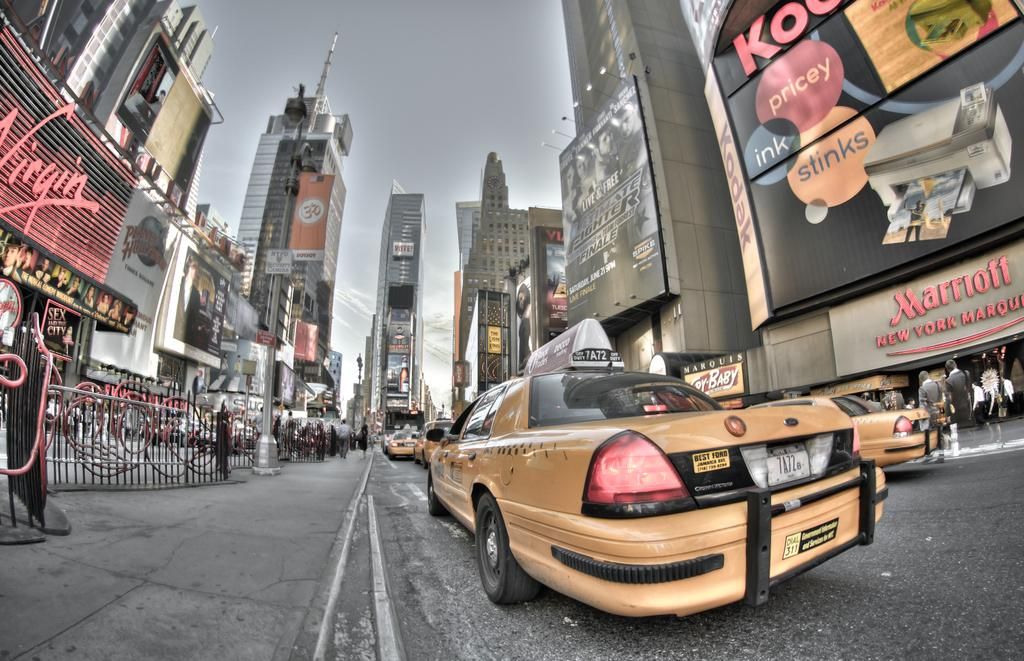Provide a one-sentence caption for the provided image. Yellow New York taxis are on the street in front of the Marriott Hotel. 